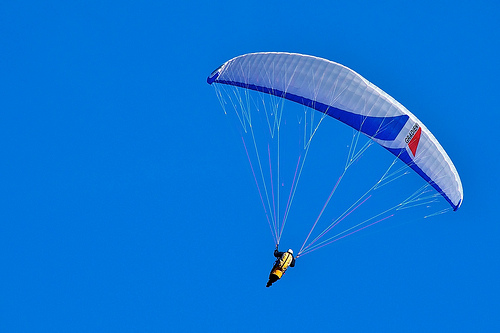What do both the parachute and the vest have in common? Both the parachute and the vest share the sharegpt4v/same yellow color. 